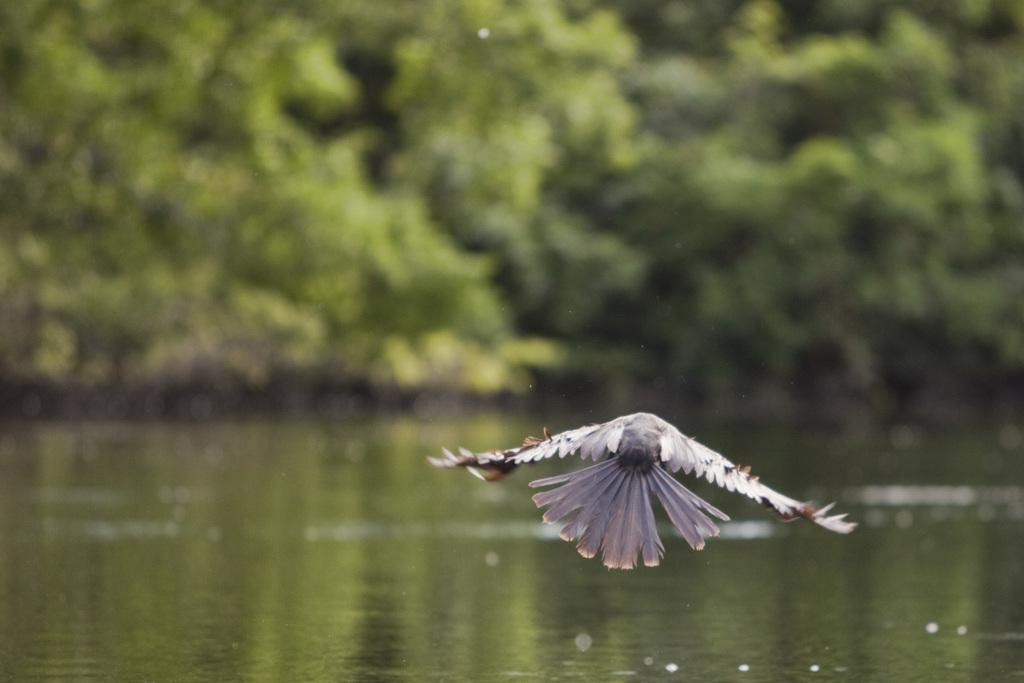What is the main subject of the image? There is a bird flying in the image. Where is the bird located in relation to the water? The bird is above water in the image. Can you describe the background of the image? The background of the image is blurred. What type of jam is being spread on the tomatoes in the image? There are no tomatoes or jam present in the image; it features a bird flying above water with a blurred background. 